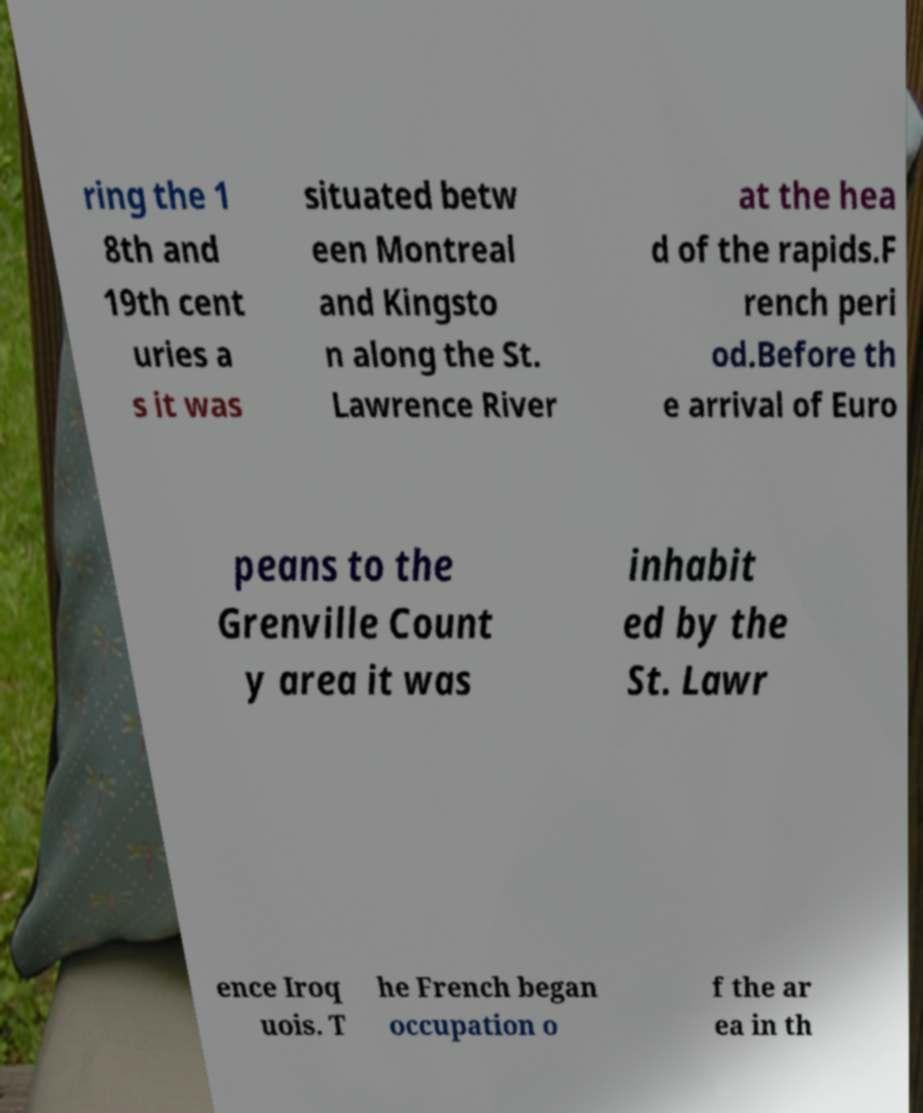I need the written content from this picture converted into text. Can you do that? ring the 1 8th and 19th cent uries a s it was situated betw een Montreal and Kingsto n along the St. Lawrence River at the hea d of the rapids.F rench peri od.Before th e arrival of Euro peans to the Grenville Count y area it was inhabit ed by the St. Lawr ence Iroq uois. T he French began occupation o f the ar ea in th 